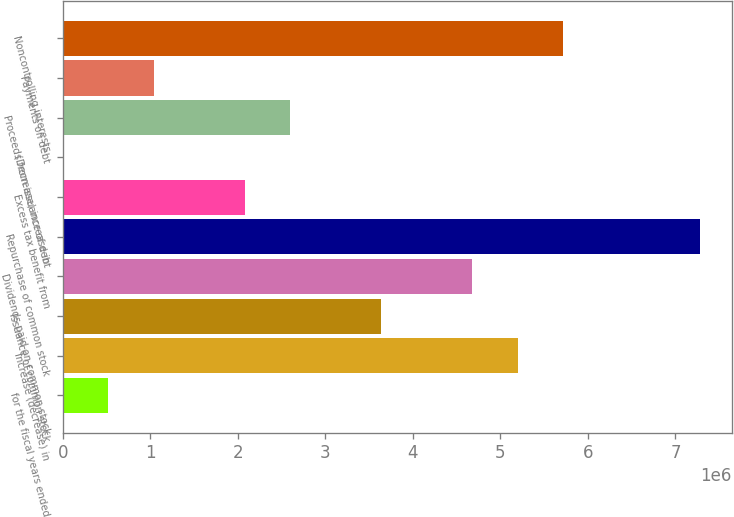Convert chart to OTSL. <chart><loc_0><loc_0><loc_500><loc_500><bar_chart><fcel>for the fiscal years ended<fcel>Increase (decrease) in<fcel>Issuance of common stock<fcel>Dividends paid on common stock<fcel>Repurchase of common stock<fcel>Excess tax benefit from<fcel>(Decrease) increase in<fcel>Proceeds from issuance of debt<fcel>Payments on debt<fcel>Noncontrolling interests<nl><fcel>519907<fcel>5.19861e+06<fcel>3.63904e+06<fcel>4.67876e+06<fcel>7.27804e+06<fcel>2.07948e+06<fcel>51<fcel>2.59933e+06<fcel>1.03976e+06<fcel>5.71847e+06<nl></chart> 